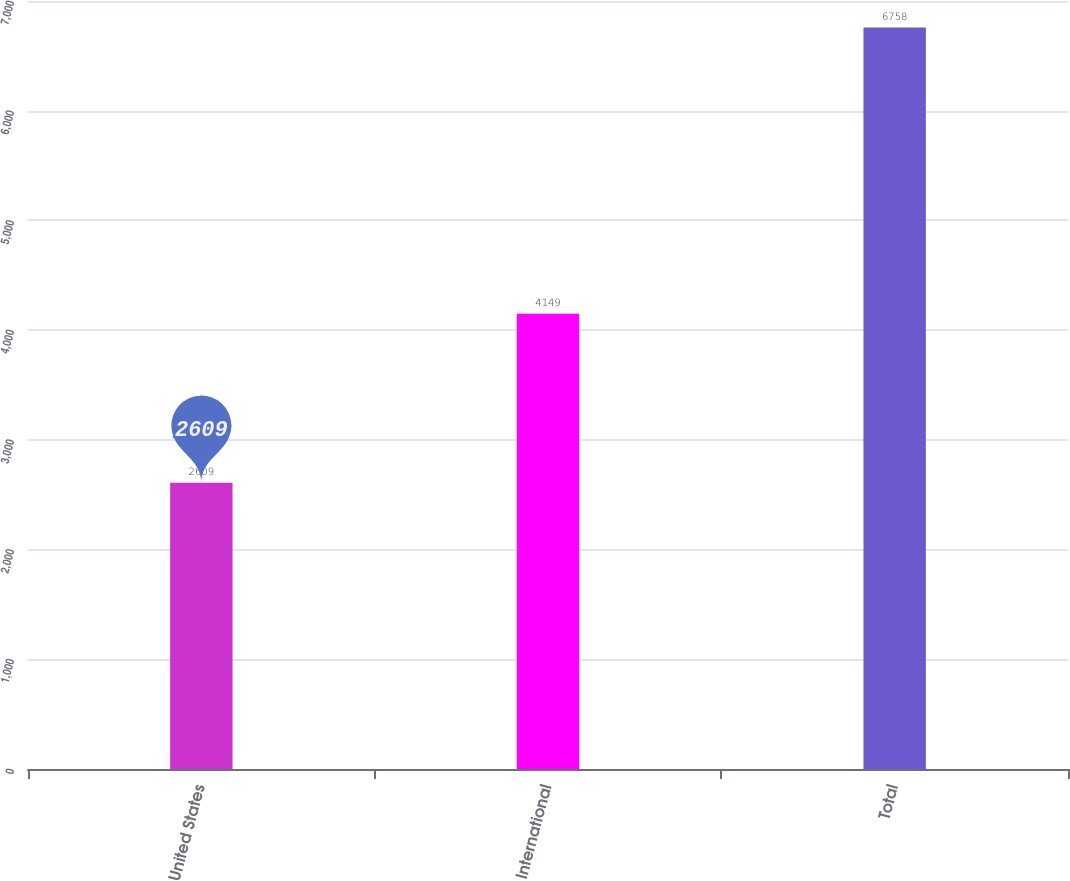Convert chart to OTSL. <chart><loc_0><loc_0><loc_500><loc_500><bar_chart><fcel>United States<fcel>International<fcel>Total<nl><fcel>2609<fcel>4149<fcel>6758<nl></chart> 